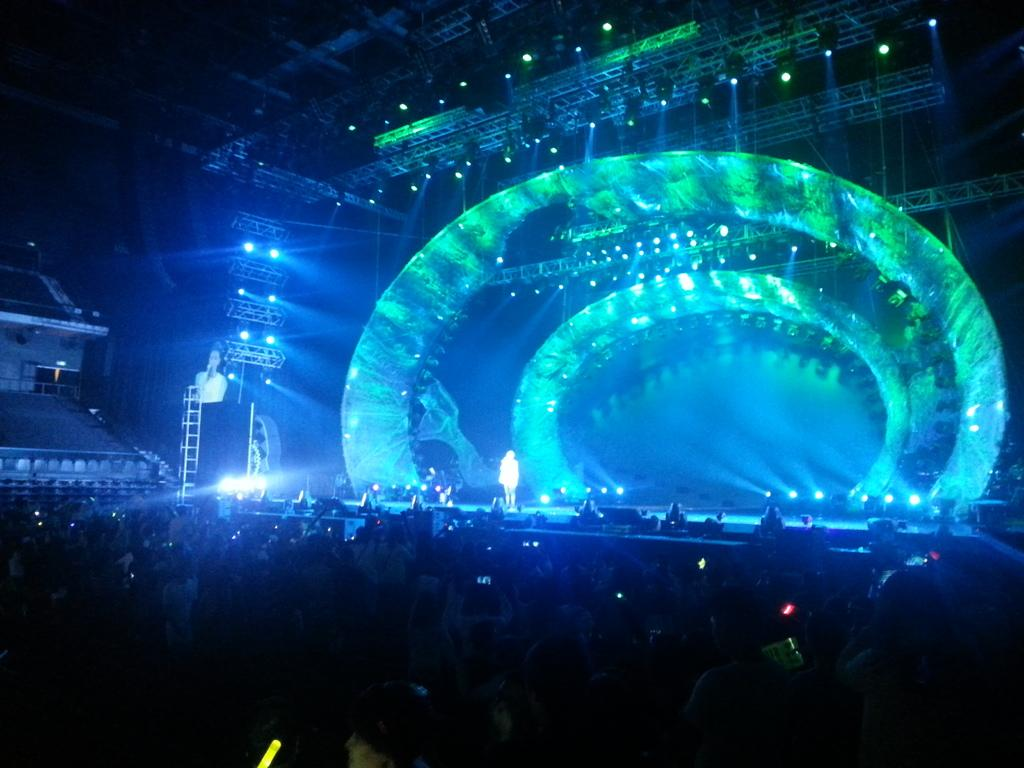How many people are in the group visible in the image? There is a group of people in the image, but the exact number is not specified. Where is the group of people located in relation to the stage? The group of people is standing near a stage. What is happening on the stage in the image? There is a person standing on the stage. What can be seen in the image that might indicate a performance or event? There are many lights visible in the image, which could suggest a performance or event. What type of coil is being used to paint the stage in the image? There is no coil or painting activity visible in the image. Where is the camp located in the image? There is no camp present in the image. 